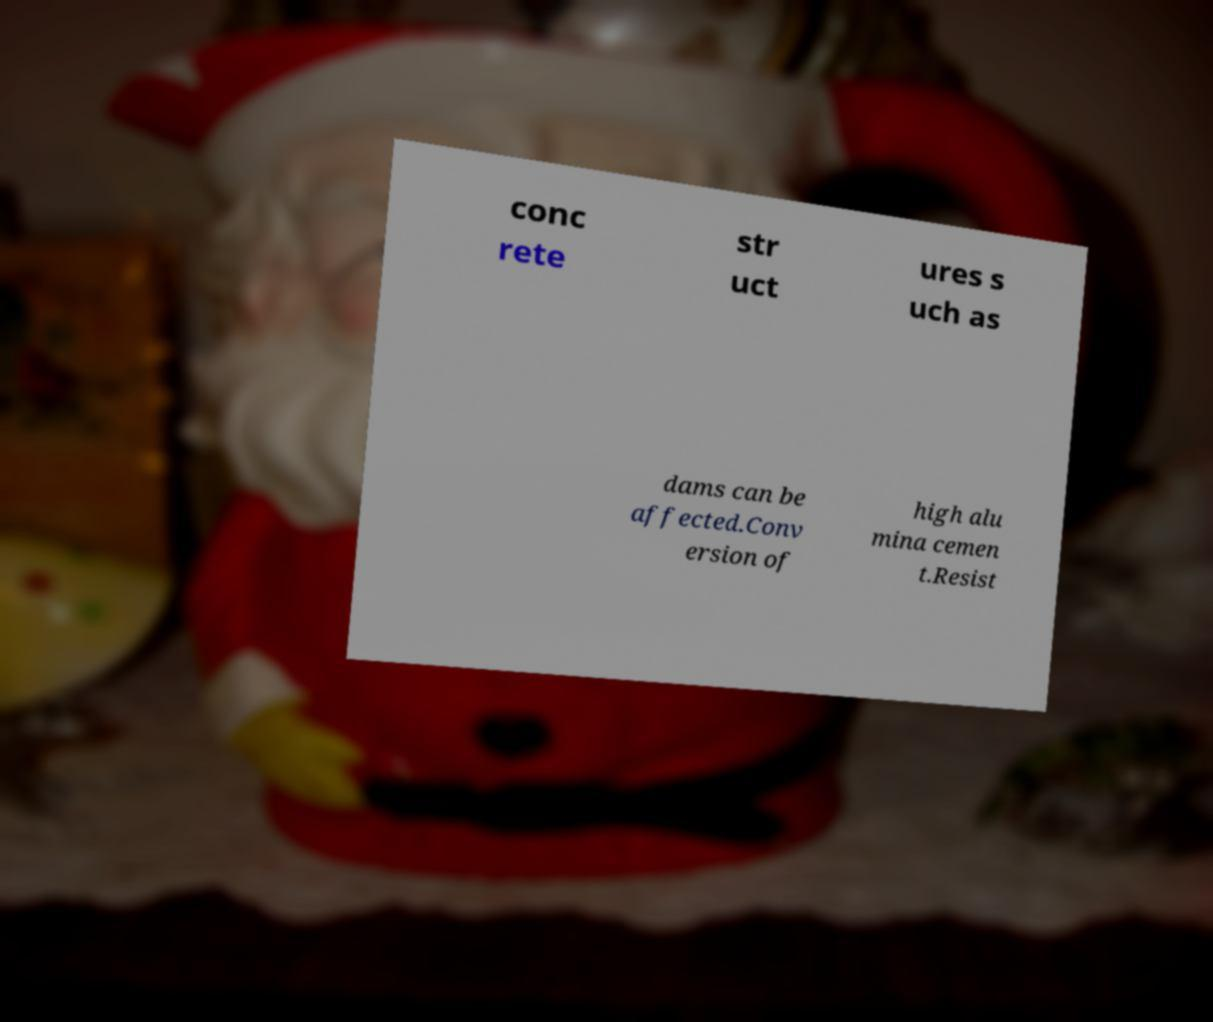I need the written content from this picture converted into text. Can you do that? conc rete str uct ures s uch as dams can be affected.Conv ersion of high alu mina cemen t.Resist 